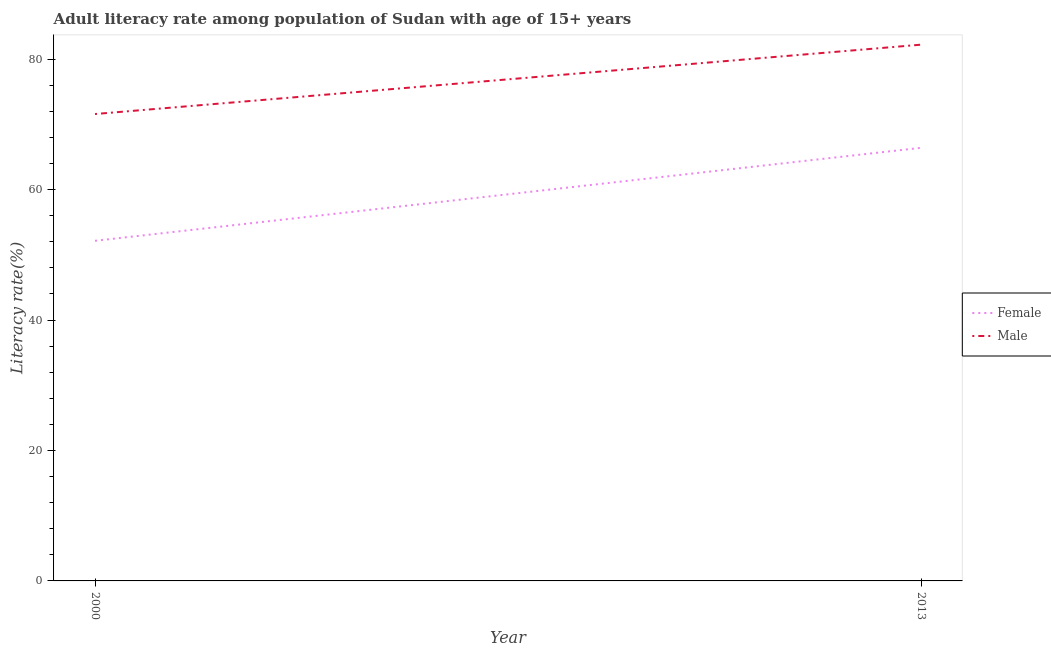Is the number of lines equal to the number of legend labels?
Keep it short and to the point. Yes. What is the female adult literacy rate in 2000?
Offer a very short reply. 52.15. Across all years, what is the maximum female adult literacy rate?
Your response must be concise. 66.4. Across all years, what is the minimum female adult literacy rate?
Your response must be concise. 52.15. In which year was the female adult literacy rate maximum?
Your answer should be compact. 2013. What is the total male adult literacy rate in the graph?
Your answer should be very brief. 153.79. What is the difference between the female adult literacy rate in 2000 and that in 2013?
Provide a succinct answer. -14.26. What is the difference between the male adult literacy rate in 2013 and the female adult literacy rate in 2000?
Keep it short and to the point. 30.07. What is the average female adult literacy rate per year?
Ensure brevity in your answer.  59.27. In the year 2013, what is the difference between the male adult literacy rate and female adult literacy rate?
Offer a very short reply. 15.81. What is the ratio of the female adult literacy rate in 2000 to that in 2013?
Keep it short and to the point. 0.79. In how many years, is the female adult literacy rate greater than the average female adult literacy rate taken over all years?
Offer a terse response. 1. Does the female adult literacy rate monotonically increase over the years?
Keep it short and to the point. Yes. Is the male adult literacy rate strictly less than the female adult literacy rate over the years?
Your answer should be very brief. No. How many lines are there?
Provide a succinct answer. 2. How many years are there in the graph?
Make the answer very short. 2. Are the values on the major ticks of Y-axis written in scientific E-notation?
Give a very brief answer. No. Does the graph contain any zero values?
Your answer should be very brief. No. Where does the legend appear in the graph?
Keep it short and to the point. Center right. How are the legend labels stacked?
Provide a succinct answer. Vertical. What is the title of the graph?
Offer a very short reply. Adult literacy rate among population of Sudan with age of 15+ years. What is the label or title of the X-axis?
Offer a terse response. Year. What is the label or title of the Y-axis?
Offer a terse response. Literacy rate(%). What is the Literacy rate(%) in Female in 2000?
Give a very brief answer. 52.15. What is the Literacy rate(%) in Male in 2000?
Provide a succinct answer. 71.58. What is the Literacy rate(%) of Female in 2013?
Offer a very short reply. 66.4. What is the Literacy rate(%) in Male in 2013?
Offer a terse response. 82.21. Across all years, what is the maximum Literacy rate(%) of Female?
Your answer should be very brief. 66.4. Across all years, what is the maximum Literacy rate(%) in Male?
Your answer should be compact. 82.21. Across all years, what is the minimum Literacy rate(%) in Female?
Offer a terse response. 52.15. Across all years, what is the minimum Literacy rate(%) of Male?
Provide a short and direct response. 71.58. What is the total Literacy rate(%) of Female in the graph?
Provide a short and direct response. 118.55. What is the total Literacy rate(%) of Male in the graph?
Ensure brevity in your answer.  153.79. What is the difference between the Literacy rate(%) in Female in 2000 and that in 2013?
Provide a succinct answer. -14.26. What is the difference between the Literacy rate(%) of Male in 2000 and that in 2013?
Give a very brief answer. -10.63. What is the difference between the Literacy rate(%) in Female in 2000 and the Literacy rate(%) in Male in 2013?
Offer a very short reply. -30.07. What is the average Literacy rate(%) in Female per year?
Your answer should be very brief. 59.27. What is the average Literacy rate(%) of Male per year?
Offer a terse response. 76.9. In the year 2000, what is the difference between the Literacy rate(%) in Female and Literacy rate(%) in Male?
Ensure brevity in your answer.  -19.43. In the year 2013, what is the difference between the Literacy rate(%) in Female and Literacy rate(%) in Male?
Give a very brief answer. -15.81. What is the ratio of the Literacy rate(%) in Female in 2000 to that in 2013?
Your answer should be compact. 0.79. What is the ratio of the Literacy rate(%) in Male in 2000 to that in 2013?
Make the answer very short. 0.87. What is the difference between the highest and the second highest Literacy rate(%) of Female?
Offer a terse response. 14.26. What is the difference between the highest and the second highest Literacy rate(%) of Male?
Offer a very short reply. 10.63. What is the difference between the highest and the lowest Literacy rate(%) in Female?
Your answer should be compact. 14.26. What is the difference between the highest and the lowest Literacy rate(%) of Male?
Offer a very short reply. 10.63. 